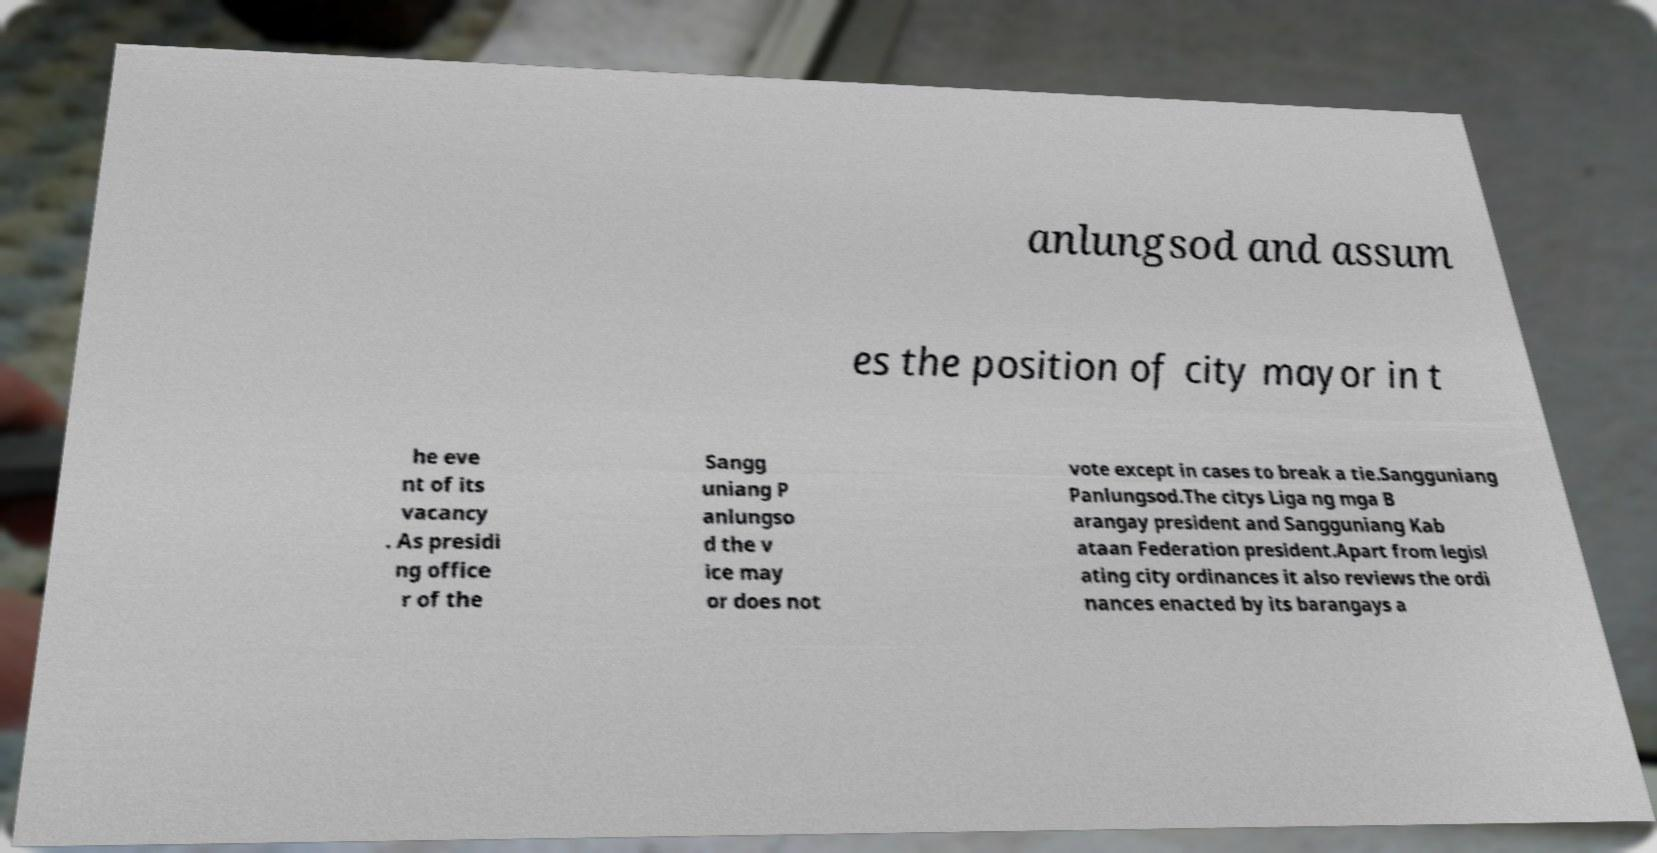Could you assist in decoding the text presented in this image and type it out clearly? anlungsod and assum es the position of city mayor in t he eve nt of its vacancy . As presidi ng office r of the Sangg uniang P anlungso d the v ice may or does not vote except in cases to break a tie.Sangguniang Panlungsod.The citys Liga ng mga B arangay president and Sangguniang Kab ataan Federation president.Apart from legisl ating city ordinances it also reviews the ordi nances enacted by its barangays a 